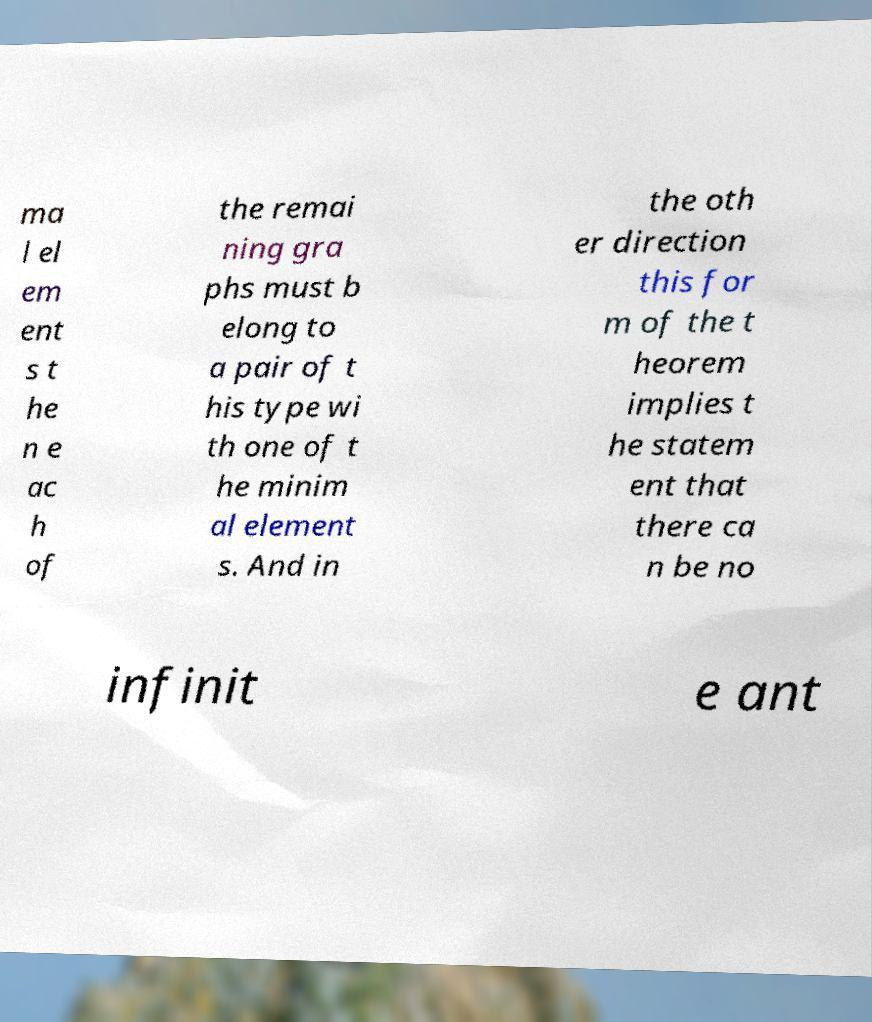There's text embedded in this image that I need extracted. Can you transcribe it verbatim? ma l el em ent s t he n e ac h of the remai ning gra phs must b elong to a pair of t his type wi th one of t he minim al element s. And in the oth er direction this for m of the t heorem implies t he statem ent that there ca n be no infinit e ant 